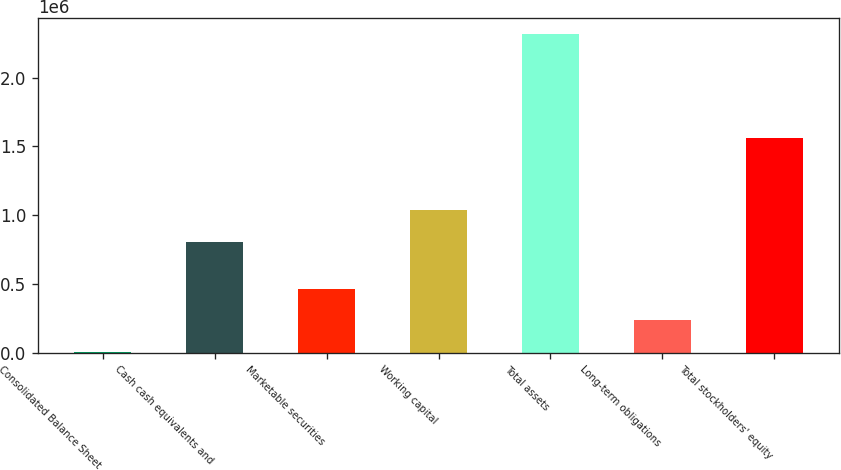Convert chart to OTSL. <chart><loc_0><loc_0><loc_500><loc_500><bar_chart><fcel>Consolidated Balance Sheet<fcel>Cash cash equivalents and<fcel>Marketable securities<fcel>Working capital<fcel>Total assets<fcel>Long-term obligations<fcel>Total stockholders' equity<nl><fcel>1999<fcel>805220<fcel>465290<fcel>1.03687e+06<fcel>2.31846e+06<fcel>233645<fcel>1.56139e+06<nl></chart> 